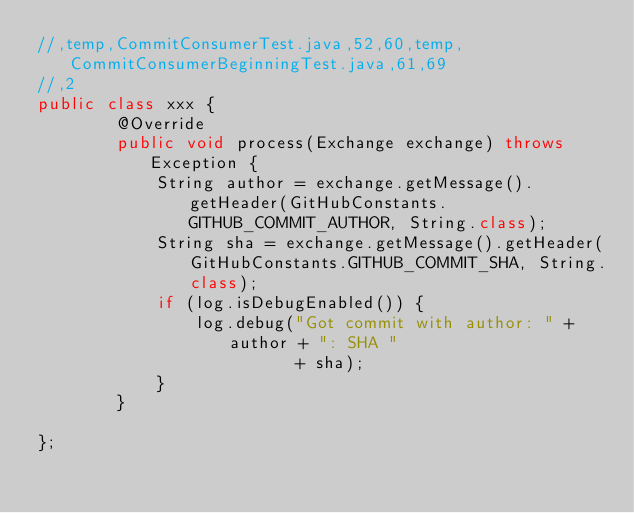Convert code to text. <code><loc_0><loc_0><loc_500><loc_500><_Java_>//,temp,CommitConsumerTest.java,52,60,temp,CommitConsumerBeginningTest.java,61,69
//,2
public class xxx {
        @Override
        public void process(Exchange exchange) throws Exception {
            String author = exchange.getMessage().getHeader(GitHubConstants.GITHUB_COMMIT_AUTHOR, String.class);
            String sha = exchange.getMessage().getHeader(GitHubConstants.GITHUB_COMMIT_SHA, String.class);
            if (log.isDebugEnabled()) {
                log.debug("Got commit with author: " + author + ": SHA "
                          + sha);
            }
        }

};</code> 